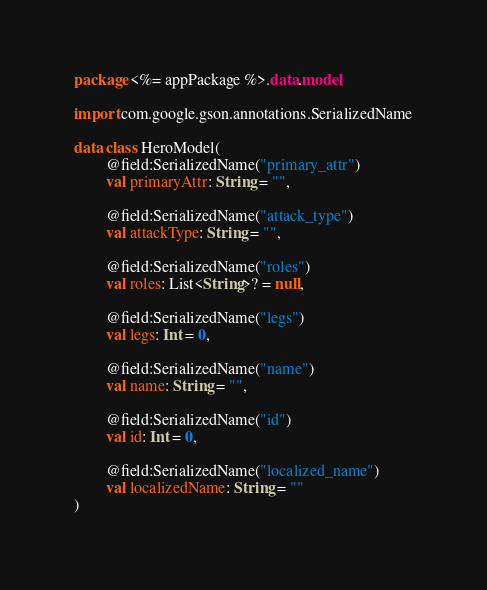Convert code to text. <code><loc_0><loc_0><loc_500><loc_500><_Kotlin_>package <%= appPackage %>.data.model

import com.google.gson.annotations.SerializedName

data class HeroModel(
        @field:SerializedName("primary_attr")
        val primaryAttr: String = "",

        @field:SerializedName("attack_type")
        val attackType: String = "",

        @field:SerializedName("roles")
        val roles: List<String>? = null,

        @field:SerializedName("legs")
        val legs: Int = 0,

        @field:SerializedName("name")
        val name: String = "",

        @field:SerializedName("id")
        val id: Int = 0,

        @field:SerializedName("localized_name")
        val localizedName: String = ""
)</code> 